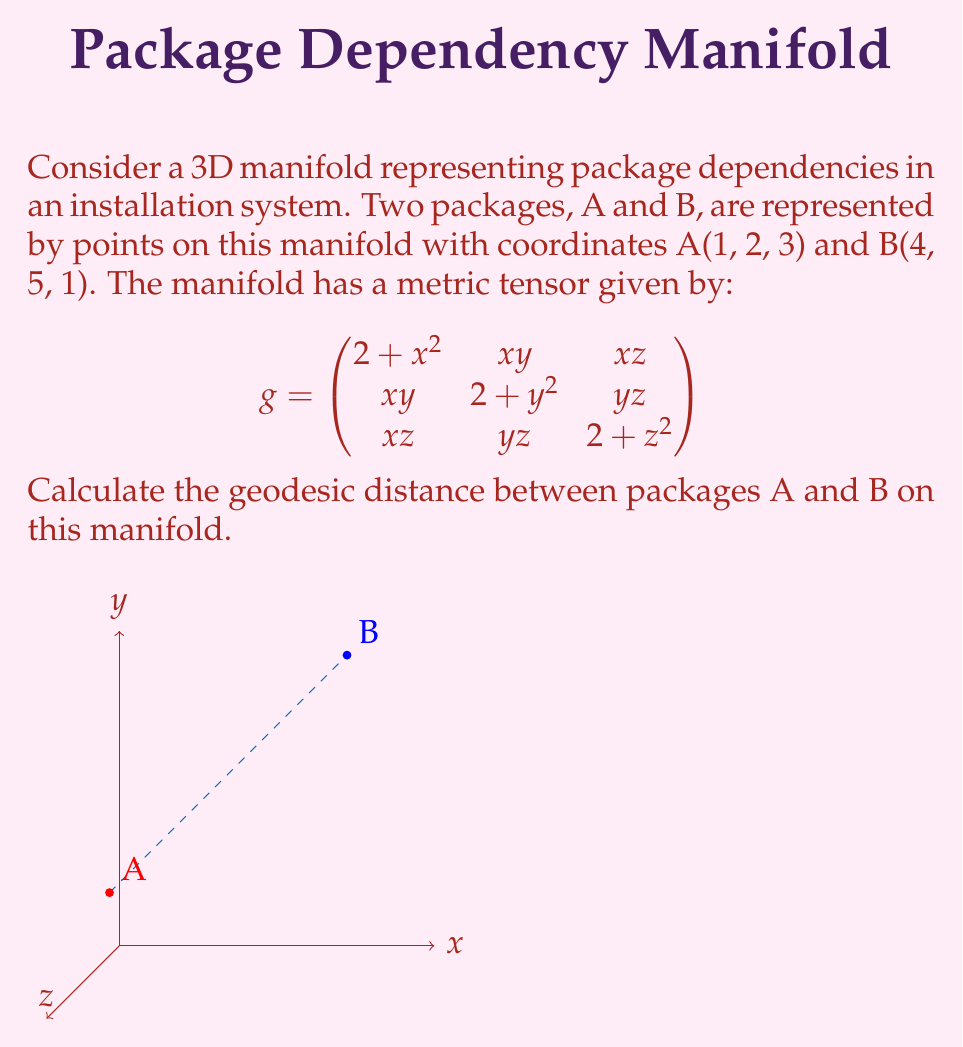Could you help me with this problem? To calculate the geodesic distance between two points on a 3D manifold, we need to follow these steps:

1) First, we need to parameterize the path between A and B. Let's use a straight line parameterization:
   $x(t) = 1 + 3t$
   $y(t) = 2 + 3t$
   $z(t) = 3 - 2t$
   where $t \in [0,1]$

2) The geodesic distance is given by the integral:
   $$L = \int_0^1 \sqrt{g_{ij}\frac{dx^i}{dt}\frac{dx^j}{dt}}dt$$

3) We need to calculate $\frac{dx^i}{dt}$:
   $\frac{dx}{dt} = 3$
   $\frac{dy}{dt} = 3$
   $\frac{dz}{dt} = -2$

4) Now, let's substitute these into the metric tensor:
   $$\begin{aligned}
   g_{ij}\frac{dx^i}{dt}\frac{dx^j}{dt} &= (2 + x^2)(3)^2 + (2 + y^2)(3)^2 + (2 + z^2)(-2)^2 \\
   &+ 2xy(3)(3) + 2xz(3)(-2) + 2yz(3)(-2)
   \end{aligned}$$

5) Substitute the parameterized coordinates:
   $x = 1 + 3t$, $y = 2 + 3t$, $z = 3 - 2t$

6) This gives us a complex function of t. To simplify, let's call this function $f(t)$:
   $$L = \int_0^1 \sqrt{f(t)}dt$$

7) This integral is too complex to solve analytically. We need to use numerical integration, such as the Simpson's rule or trapezoidal rule.

8) Using a numerical integration method (e.g., Simpson's rule with 1000 subintervals), we can approximate the value of the integral.
Answer: $L \approx 5.8762$ (units of the manifold) 